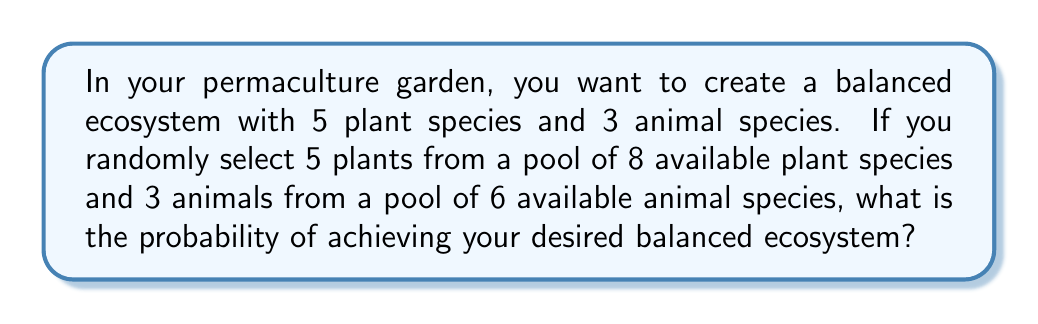Give your solution to this math problem. Let's approach this step-by-step:

1) First, we need to calculate the number of ways to select 5 plants from 8 available species. This is a combination problem, represented as $\binom{8}{5}$. The formula for this combination is:

   $$\binom{8}{5} = \frac{8!}{5!(8-5)!} = \frac{8!}{5!3!} = 56$$

2) Next, we calculate the number of ways to select 3 animals from 6 available species. This is represented as $\binom{6}{3}$:

   $$\binom{6}{3} = \frac{6!}{3!(6-3)!} = \frac{6!}{3!3!} = 20$$

3) The total number of possible outcomes is the product of these two combinations:

   $$56 \times 20 = 1120$$

4) This represents all possible ways to select 5 plants and 3 animals from the available pools.

5) However, we're only interested in one specific outcome (the desired balanced ecosystem), which is just 1 out of these 1120 possibilities.

6) Therefore, the probability is:

   $$P(\text{balanced ecosystem}) = \frac{1}{1120}$$
Answer: $\frac{1}{1120}$ 